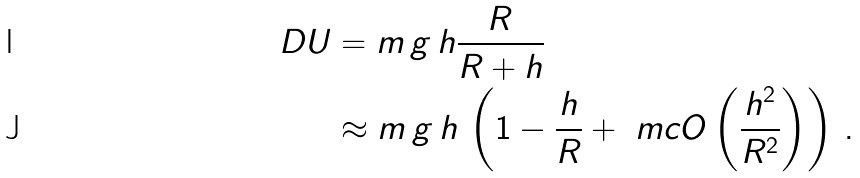Convert formula to latex. <formula><loc_0><loc_0><loc_500><loc_500>\ D U & = m \, g \, h \frac { R } { R + h } \\ & \approx m \, g \, h \, \left ( 1 - \frac { h } { R } + \ m c { O } \left ( \frac { h ^ { 2 } } { R ^ { 2 } } \right ) \right ) \, .</formula> 